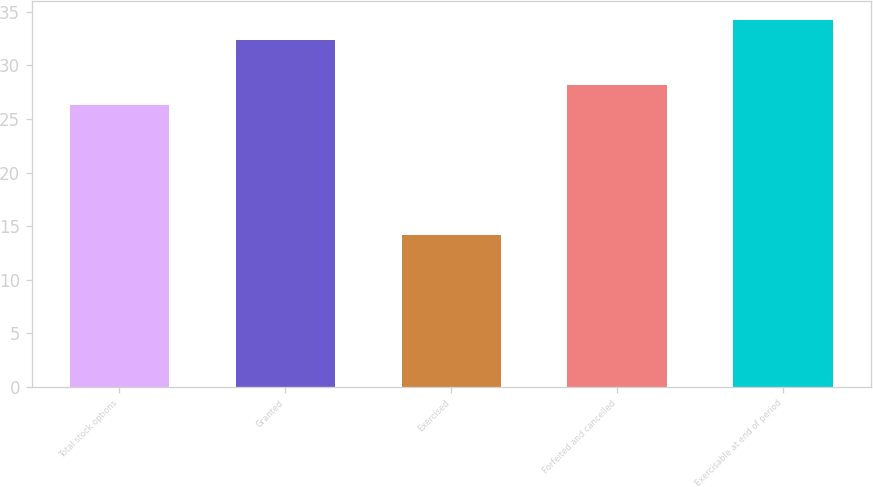<chart> <loc_0><loc_0><loc_500><loc_500><bar_chart><fcel>Total stock options<fcel>Granted<fcel>Exercised<fcel>Forfeited and cancelled<fcel>Exercisable at end of period<nl><fcel>26.3<fcel>32.41<fcel>14.14<fcel>28.17<fcel>34.28<nl></chart> 